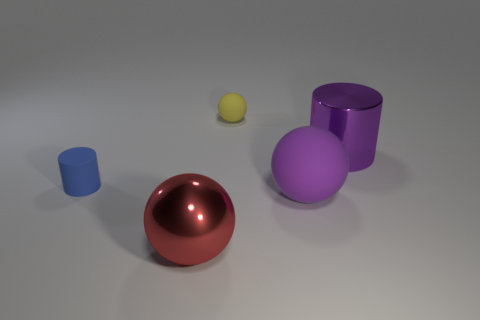Add 4 gray cylinders. How many objects exist? 9 Subtract all metal balls. How many balls are left? 2 Subtract all cylinders. How many objects are left? 3 Subtract all gray spheres. How many red cylinders are left? 0 Subtract all metallic balls. Subtract all cyan shiny objects. How many objects are left? 4 Add 3 large purple matte things. How many large purple matte things are left? 4 Add 4 tiny yellow matte objects. How many tiny yellow matte objects exist? 5 Subtract all red spheres. How many spheres are left? 2 Subtract 0 cyan spheres. How many objects are left? 5 Subtract 1 cylinders. How many cylinders are left? 1 